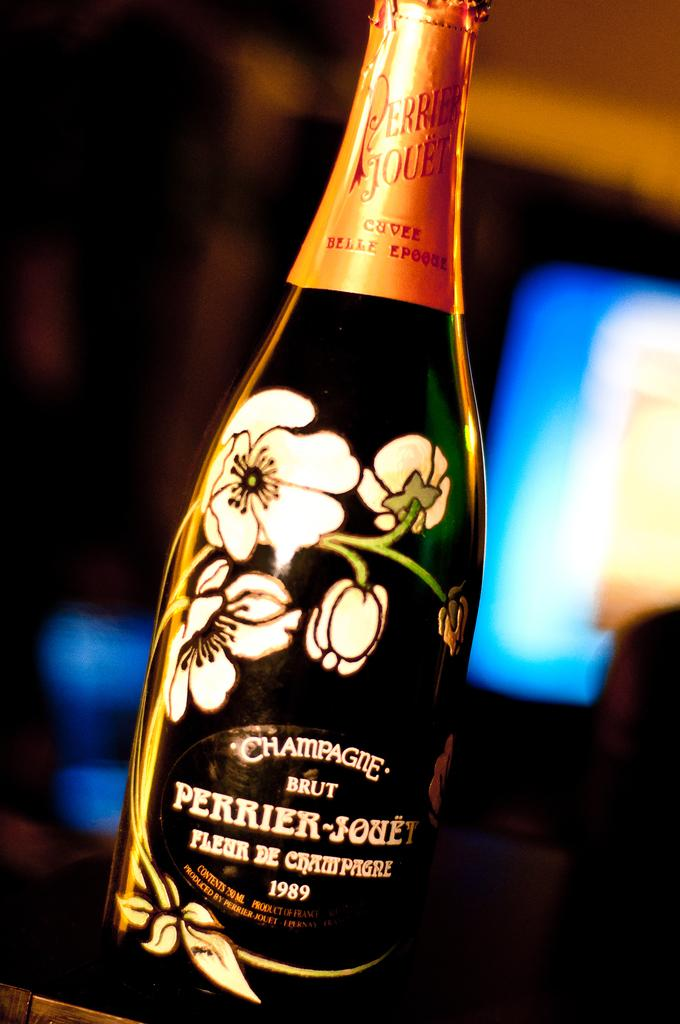<image>
Provide a brief description of the given image. An unopened bottle of Perrier-Jouet champagne from 1989. 